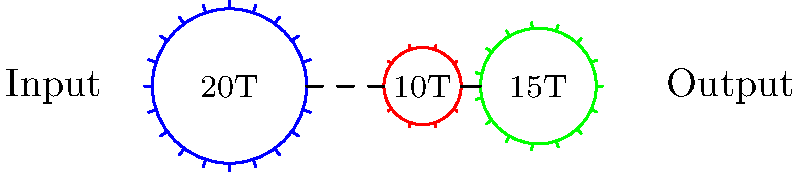In the transmission system shown above, what is the overall gear ratio and how does it affect the power output compared to the input? Assume the input power is 50 kW and neglect any power losses in the system. To solve this problem, we'll follow these steps:

1. Calculate the overall gear ratio:
   - Gear ratio = (Product of driven gears) / (Product of driving gears)
   - In this case: $\text{Gear ratio} = \frac{10 \times 15}{20} = \frac{150}{20} = 7.5$

2. Understand the relationship between gear ratio, speed, and torque:
   - When gear ratio > 1, output speed decreases, but output torque increases
   - $\text{Output speed} = \frac{\text{Input speed}}{\text{Gear ratio}}$
   - $\text{Output torque} = \text{Input torque} \times \text{Gear ratio}$

3. Recall the relationship between power, speed, and torque:
   $P = \tau \omega$
   Where $P$ is power, $\tau$ is torque, and $\omega$ is angular velocity (speed)

4. Analyze the effect on power:
   - Input power = Output power (assuming no losses)
   - $P_{\text{in}} = \tau_{\text{in}} \omega_{\text{in}} = 50 \text{ kW}$
   - $P_{\text{out}} = \tau_{\text{out}} \omega_{\text{out}} = 50 \text{ kW}$

   Since $\tau_{\text{out}} = 7.5 \tau_{\text{in}}$ and $\omega_{\text{out}} = \frac{\omega_{\text{in}}}{7.5}$, we can see that:

   $P_{\text{out}} = (7.5 \tau_{\text{in}}) (\frac{\omega_{\text{in}}}{7.5}) = \tau_{\text{in}} \omega_{\text{in}} = P_{\text{in}}$

Thus, the power output remains the same as the input power, but with increased torque and decreased speed.
Answer: Gear ratio: 7.5; Power output remains 50 kW, with increased torque and decreased speed. 